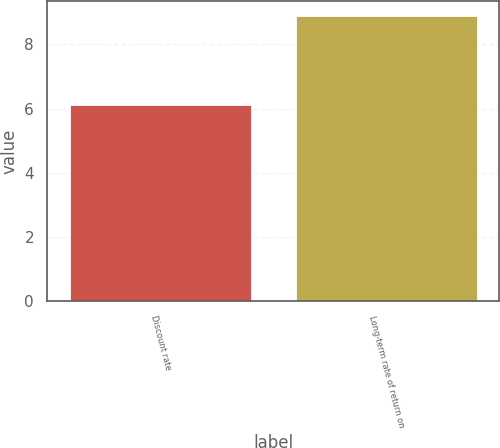Convert chart to OTSL. <chart><loc_0><loc_0><loc_500><loc_500><bar_chart><fcel>Discount rate<fcel>Long-term rate of return on<nl><fcel>6.1<fcel>8.9<nl></chart> 